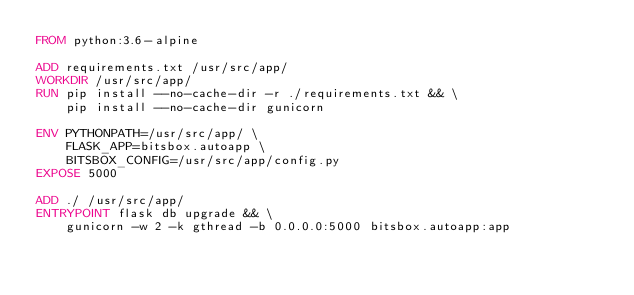<code> <loc_0><loc_0><loc_500><loc_500><_Dockerfile_>FROM python:3.6-alpine

ADD requirements.txt /usr/src/app/
WORKDIR /usr/src/app/
RUN pip install --no-cache-dir -r ./requirements.txt && \
	pip install --no-cache-dir gunicorn

ENV PYTHONPATH=/usr/src/app/ \
	FLASK_APP=bitsbox.autoapp \
	BITSBOX_CONFIG=/usr/src/app/config.py
EXPOSE 5000

ADD ./ /usr/src/app/
ENTRYPOINT flask db upgrade && \
	gunicorn -w 2 -k gthread -b 0.0.0.0:5000 bitsbox.autoapp:app
</code> 